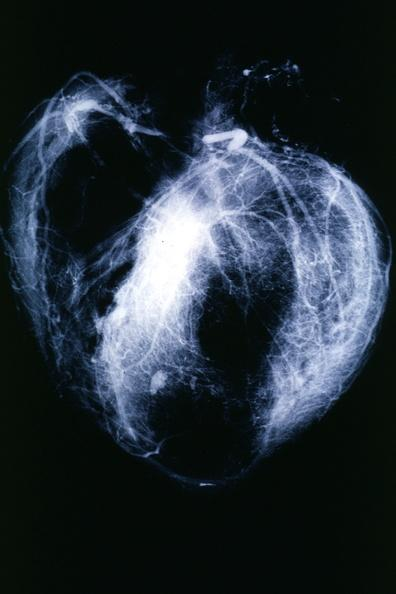where is this from?
Answer the question using a single word or phrase. Heart 